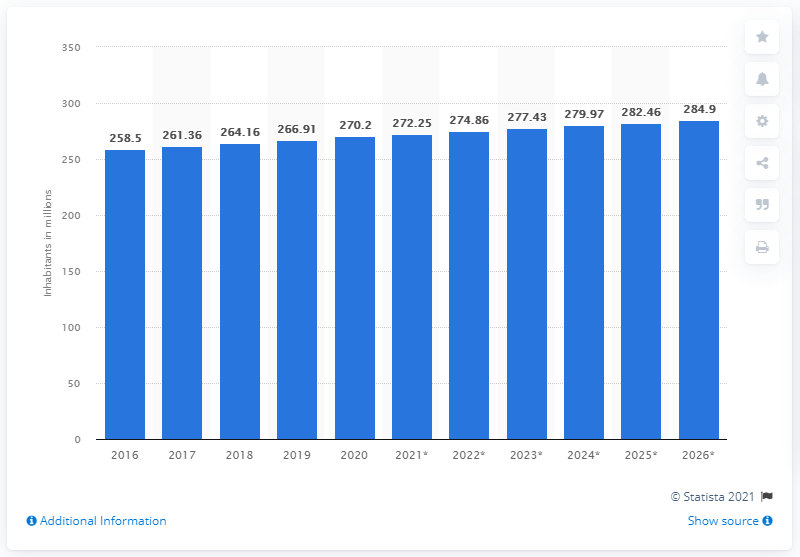Highlight a few significant elements in this photo. In 2020, the total population of Indonesia underwent a significant change, as compared to 2016. In 2020, the population of Indonesia was approximately 272.25 million people. 